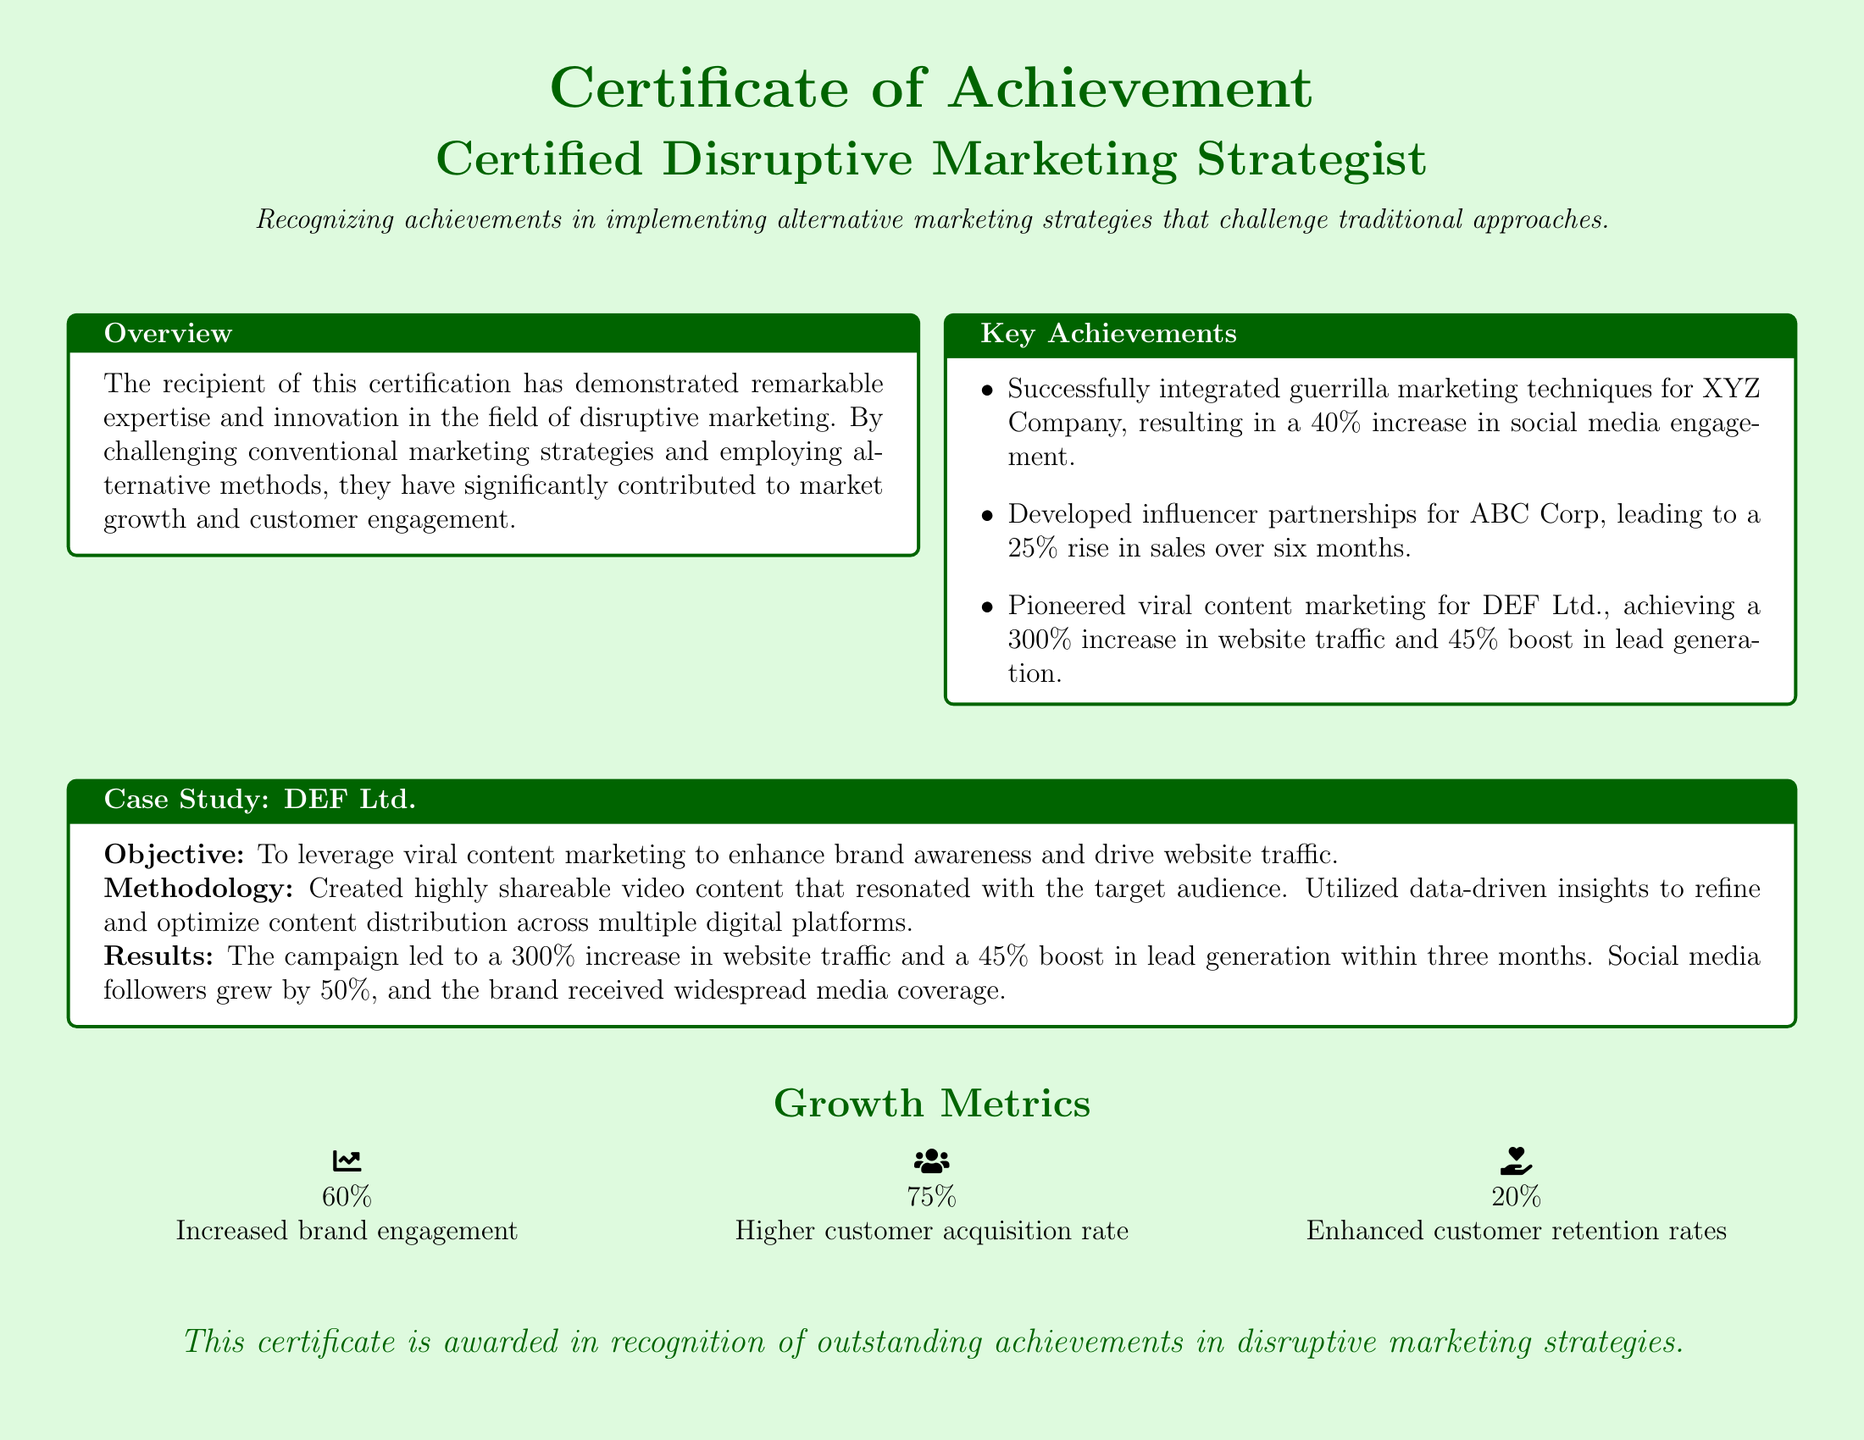What is the title of the certificate? The title of the certificate is presented prominently at the top of the document.
Answer: Certified Disruptive Marketing Strategist What is the percentage increase in social media engagement for XYZ Company? The document specifies the result of integrating guerrilla marketing techniques for XYZ Company.
Answer: 40% What company is associated with viral content marketing in the case study? The case study specifically mentions the company that utilized viral content marketing for their branding efforts.
Answer: DEF Ltd What was the increase in website traffic achieved through the campaign for DEF Ltd.? The results section of the case study provides specific metrics related to website traffic increases.
Answer: 300% What percentage increase in sales was noted for ABC Corp? The document lists the achievements regarding influencer partnerships for a particular corporation.
Answer: 25% What was the boost in lead generation from the DEF Ltd. campaign? The results section of the case study quantifies the lead generation increase resulting from their marketing strategy.
Answer: 45% What was the overall increase in brand engagement as mentioned in the growth metrics? The growth metrics detail the percentage growth in brand engagement as a result of the marketing strategies implemented.
Answer: 60% How much higher was the customer acquisition rate? The growth metrics indicate a specific percentage for the increase in the customer acquisition rate.
Answer: 75% What type of marketing strategy is primarily recognized by this certificate? The document identifies the marketing approach that the certificate aims to acknowledge.
Answer: Disruptive marketing strategies 